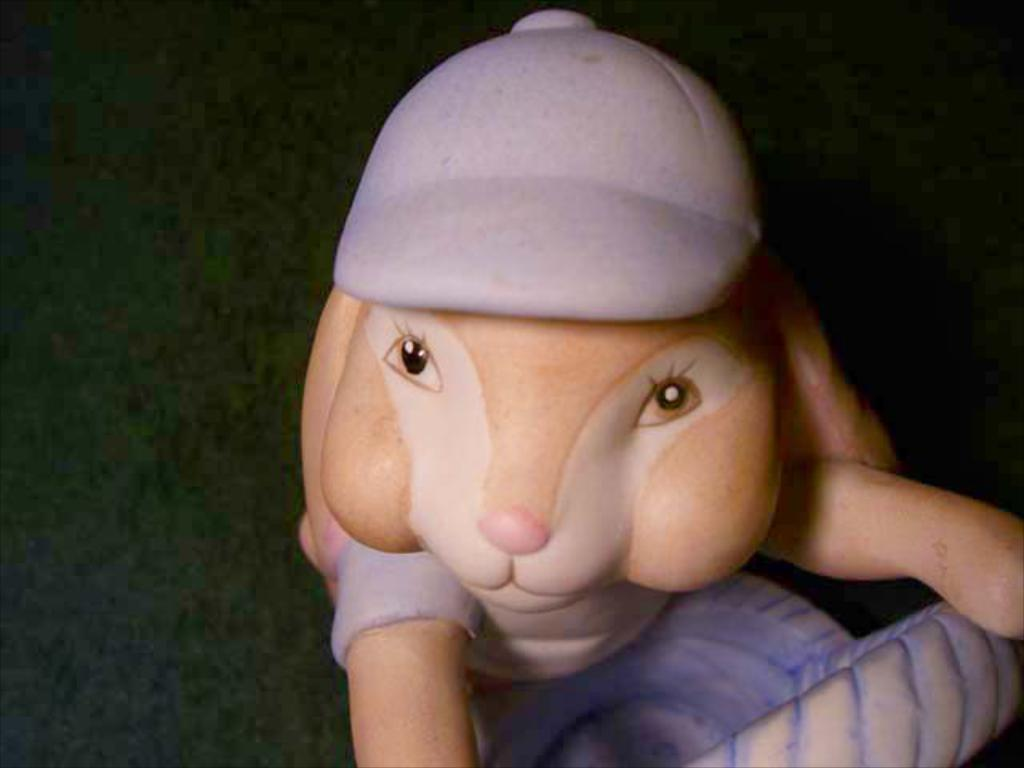What object can be seen in the image? There is a toy in the image. What is the toy wearing? The toy is wearing a cap. What can be observed about the background of the image? The background of the image is dark. Are there any fairies flying around the toy in the image? There are no fairies present in the image. What news is being reported by the toy in the image? The toy is not reporting any news in the image, as it is a toy and not capable of reporting news. 